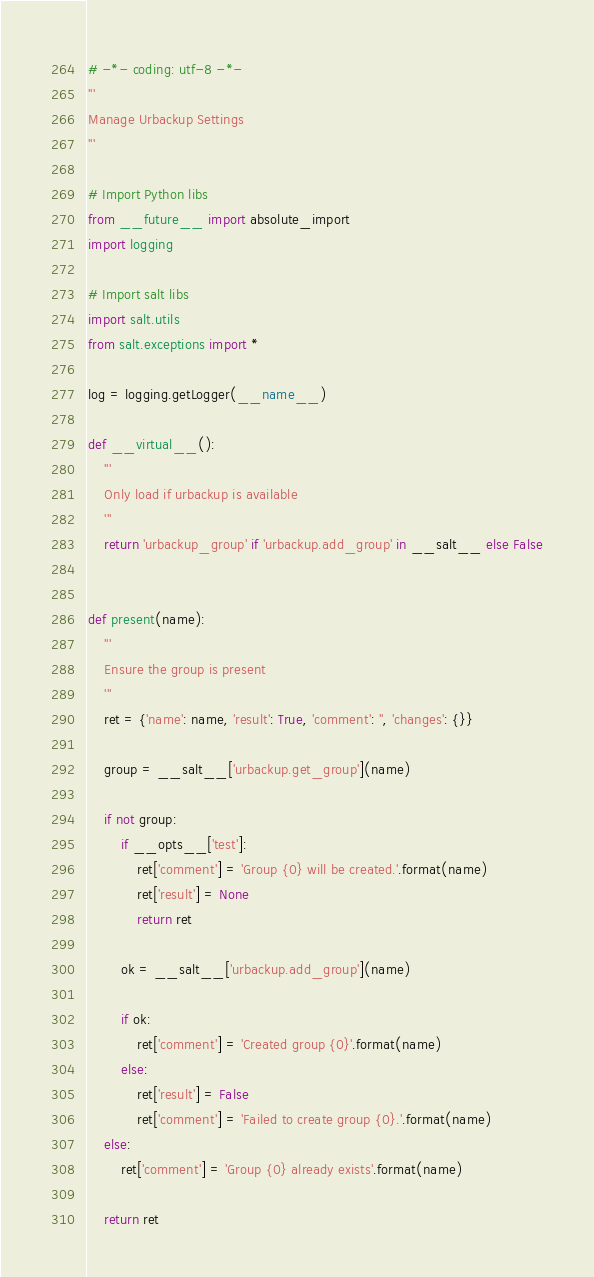<code> <loc_0><loc_0><loc_500><loc_500><_Python_># -*- coding: utf-8 -*-
'''
Manage Urbackup Settings
'''

# Import Python libs
from __future__ import absolute_import
import logging

# Import salt libs
import salt.utils
from salt.exceptions import *

log = logging.getLogger(__name__)

def __virtual__():
    '''
    Only load if urbackup is available
    '''
    return 'urbackup_group' if 'urbackup.add_group' in __salt__ else False


def present(name):
    '''
    Ensure the group is present
    '''
    ret = {'name': name, 'result': True, 'comment': '', 'changes': {}}

    group = __salt__['urbackup.get_group'](name)

    if not group:
        if __opts__['test']:
            ret['comment'] = 'Group {0} will be created.'.format(name)
            ret['result'] = None
            return ret

        ok = __salt__['urbackup.add_group'](name)

        if ok:
            ret['comment'] = 'Created group {0}'.format(name)
        else:
            ret['result'] = False
            ret['comment'] = 'Failed to create group {0}.'.format(name)
    else:
        ret['comment'] = 'Group {0} already exists'.format(name)

    return ret
</code> 